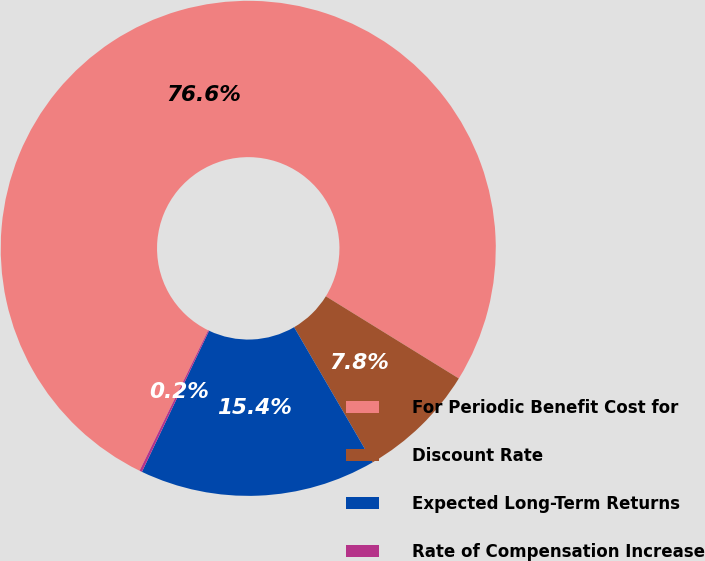Convert chart to OTSL. <chart><loc_0><loc_0><loc_500><loc_500><pie_chart><fcel>For Periodic Benefit Cost for<fcel>Discount Rate<fcel>Expected Long-Term Returns<fcel>Rate of Compensation Increase<nl><fcel>76.58%<fcel>7.81%<fcel>15.45%<fcel>0.17%<nl></chart> 